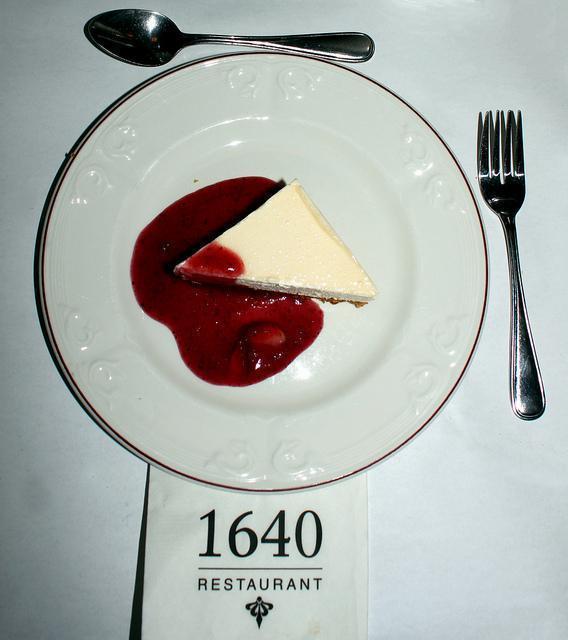What is on the plate?
Choose the correct response, then elucidate: 'Answer: answer
Rationale: rationale.'
Options: Pear, apple, sausage, cake. Answer: cake.
Rationale: There is cheesecake. 